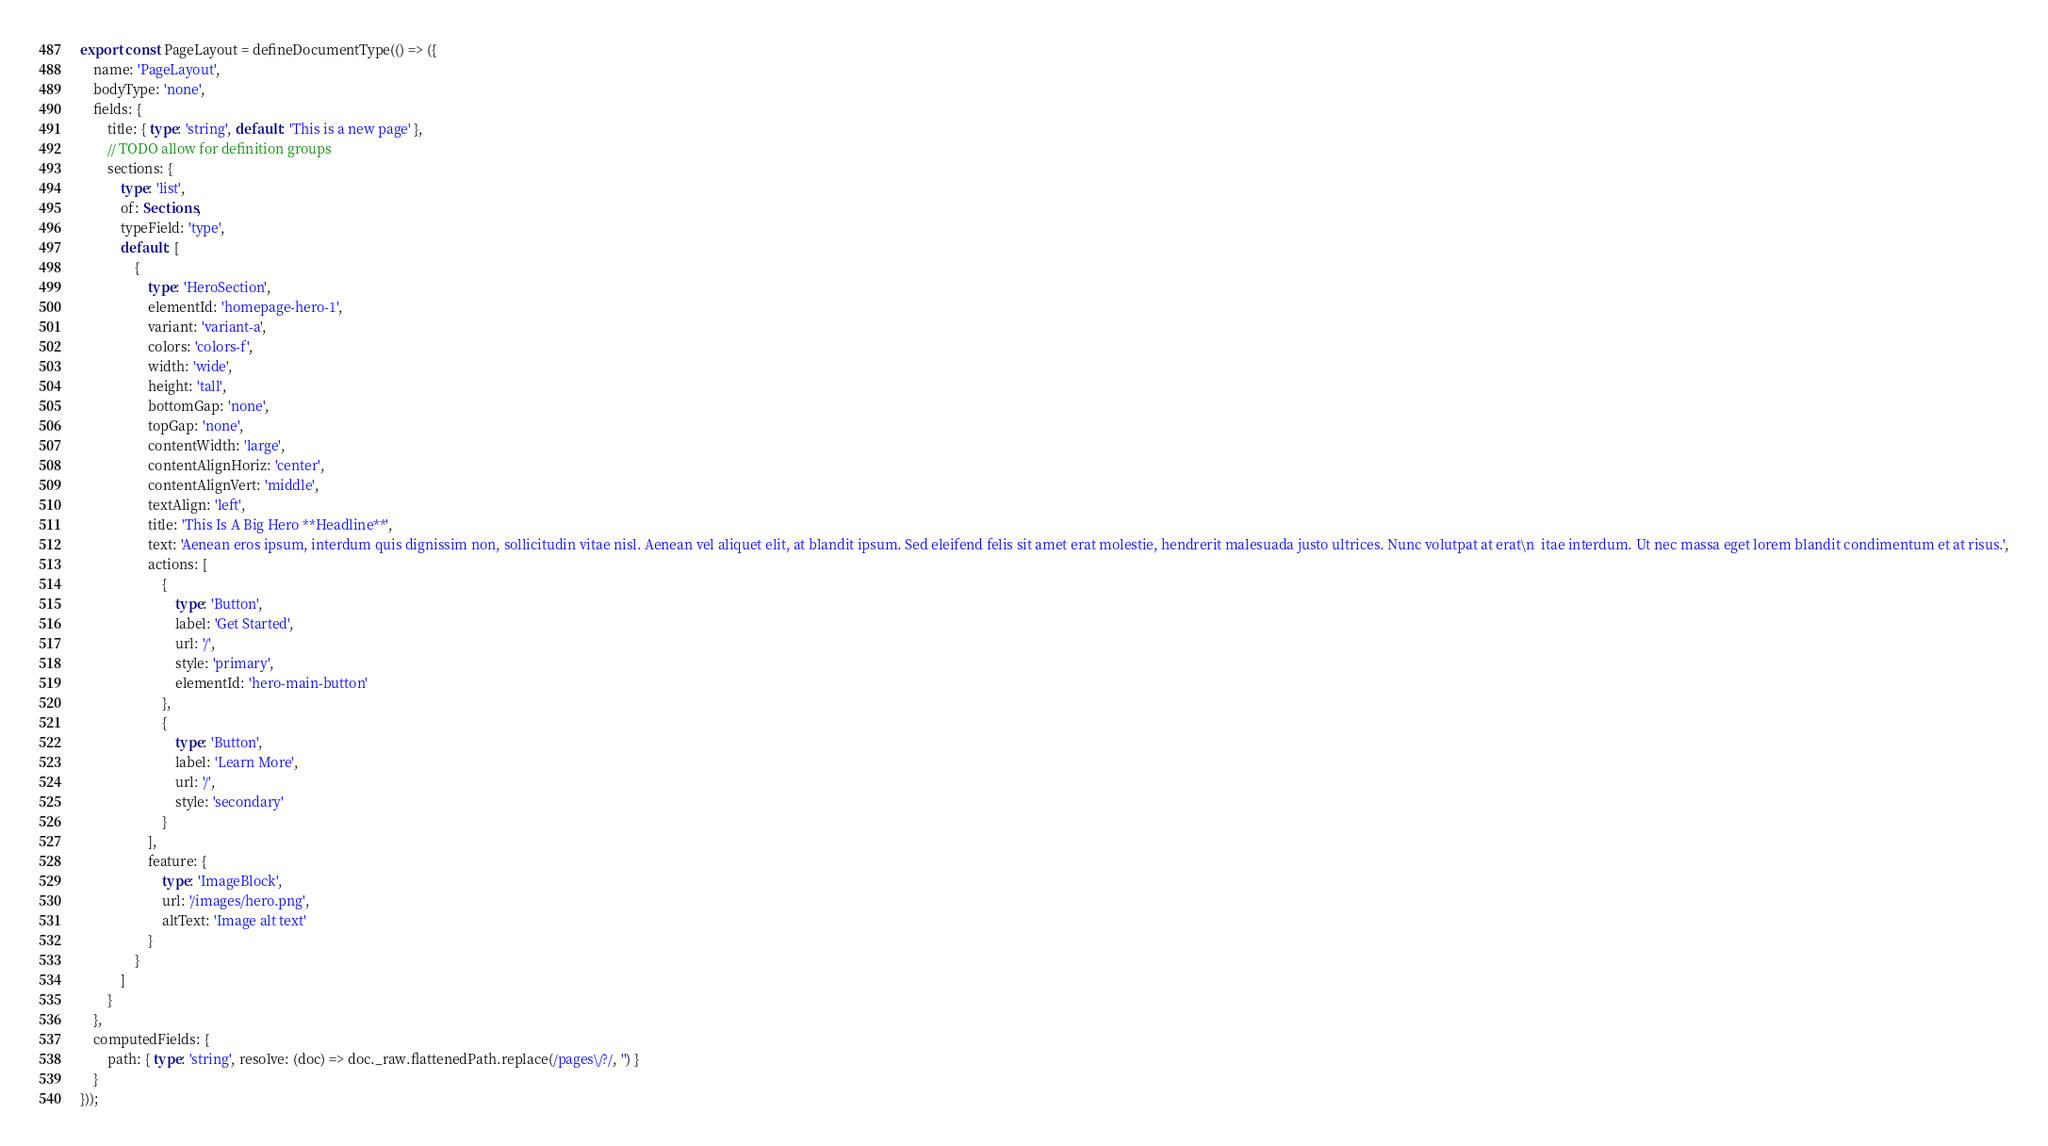Convert code to text. <code><loc_0><loc_0><loc_500><loc_500><_TypeScript_>export const PageLayout = defineDocumentType(() => ({
    name: 'PageLayout',
    bodyType: 'none',
    fields: {
        title: { type: 'string', default: 'This is a new page' },
        // TODO allow for definition groups
        sections: {
            type: 'list',
            of: Sections,
            typeField: 'type',
            default: [
                {
                    type: 'HeroSection',
                    elementId: 'homepage-hero-1',
                    variant: 'variant-a',
                    colors: 'colors-f',
                    width: 'wide',
                    height: 'tall',
                    bottomGap: 'none',
                    topGap: 'none',
                    contentWidth: 'large',
                    contentAlignHoriz: 'center',
                    contentAlignVert: 'middle',
                    textAlign: 'left',
                    title: 'This Is A Big Hero **Headline**',
                    text: 'Aenean eros ipsum, interdum quis dignissim non, sollicitudin vitae nisl. Aenean vel aliquet elit, at blandit ipsum. Sed eleifend felis sit amet erat molestie, hendrerit malesuada justo ultrices. Nunc volutpat at erat\n  itae interdum. Ut nec massa eget lorem blandit condimentum et at risus.',
                    actions: [
                        {
                            type: 'Button',
                            label: 'Get Started',
                            url: '/',
                            style: 'primary',
                            elementId: 'hero-main-button'
                        },
                        {
                            type: 'Button',
                            label: 'Learn More',
                            url: '/',
                            style: 'secondary'
                        }
                    ],
                    feature: {
                        type: 'ImageBlock',
                        url: '/images/hero.png',
                        altText: 'Image alt text'
                    }
                }
            ]
        }
    },
    computedFields: {
        path: { type: 'string', resolve: (doc) => doc._raw.flattenedPath.replace(/pages\/?/, '') }
    }
}));
</code> 